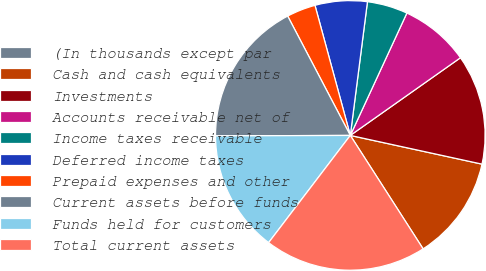<chart> <loc_0><loc_0><loc_500><loc_500><pie_chart><fcel>(In thousands except par<fcel>Cash and cash equivalents<fcel>Investments<fcel>Accounts receivable net of<fcel>Income taxes receivable<fcel>Deferred income taxes<fcel>Prepaid expenses and other<fcel>Current assets before funds<fcel>Funds held for customers<fcel>Total current assets<nl><fcel>0.0%<fcel>12.5%<fcel>13.19%<fcel>8.33%<fcel>4.86%<fcel>6.25%<fcel>3.47%<fcel>17.36%<fcel>14.58%<fcel>19.44%<nl></chart> 